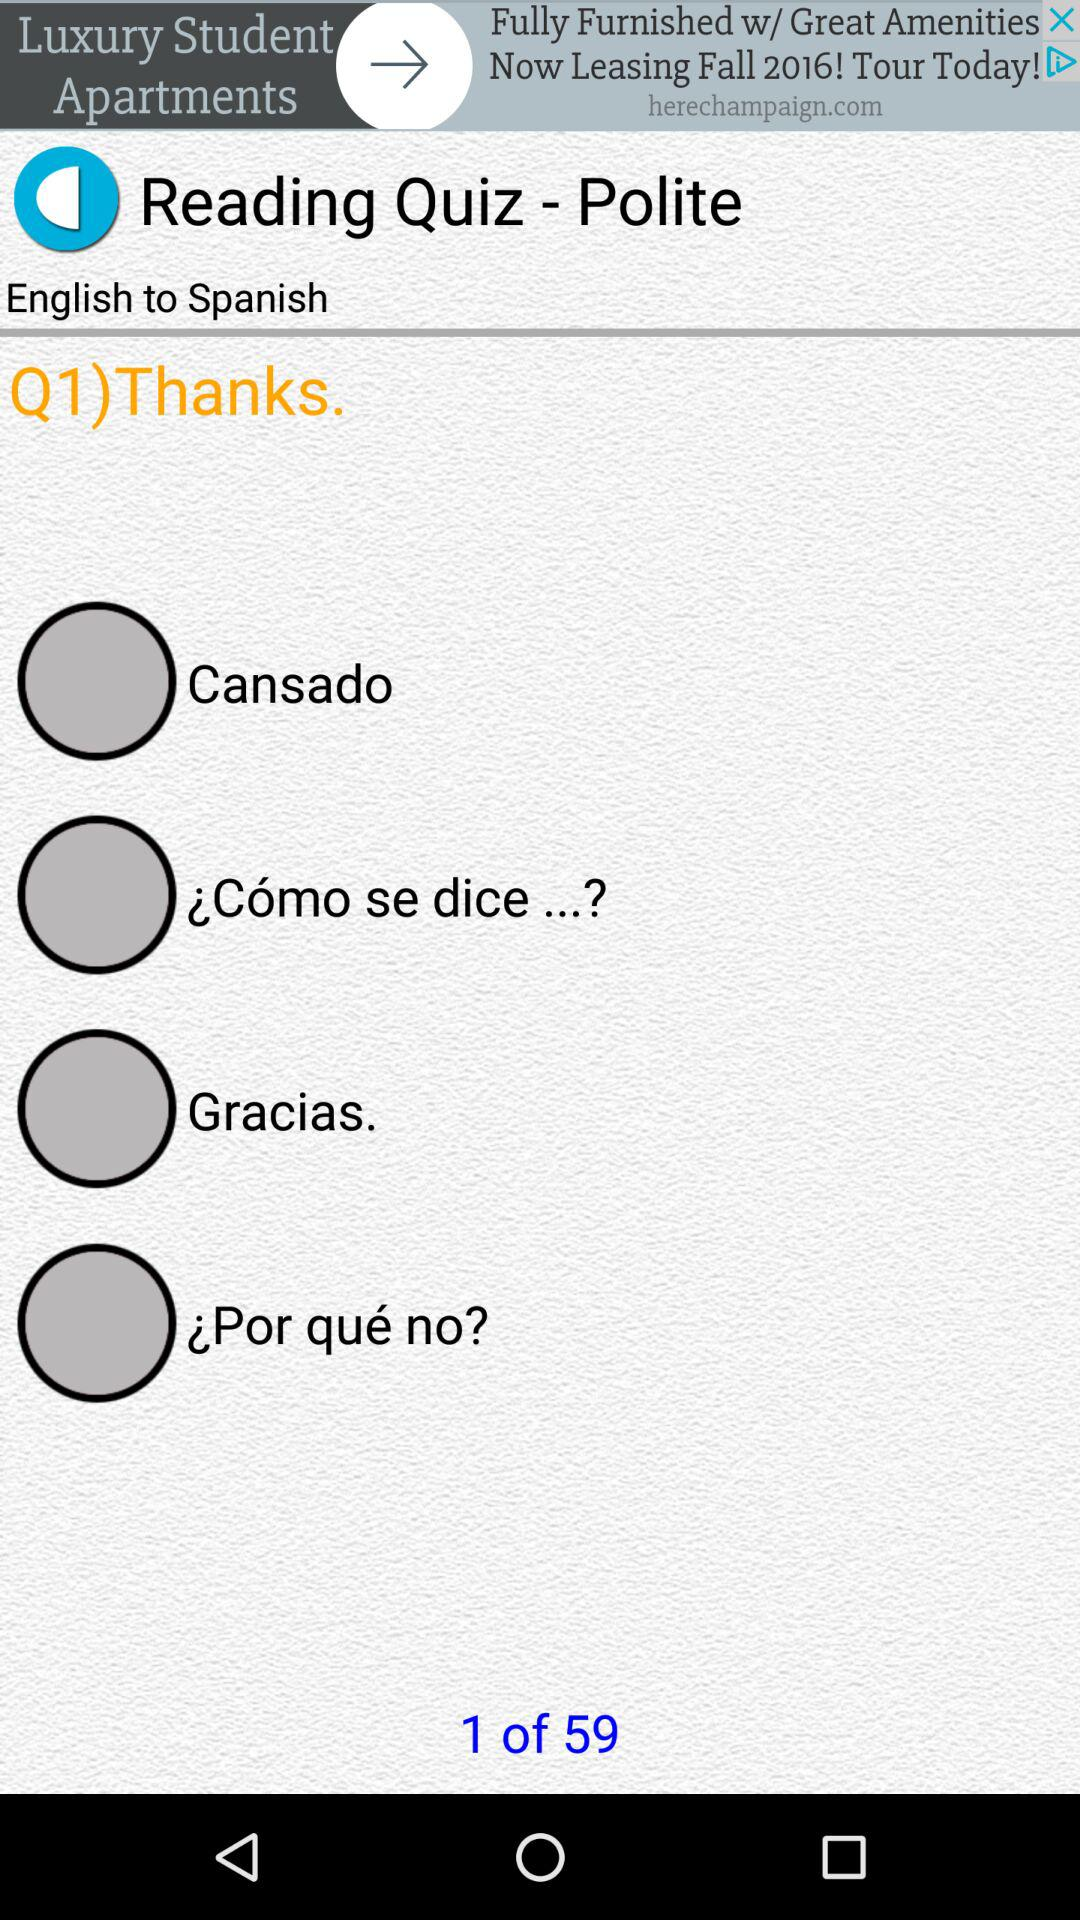Which question is the person on? The person is on the first question. 